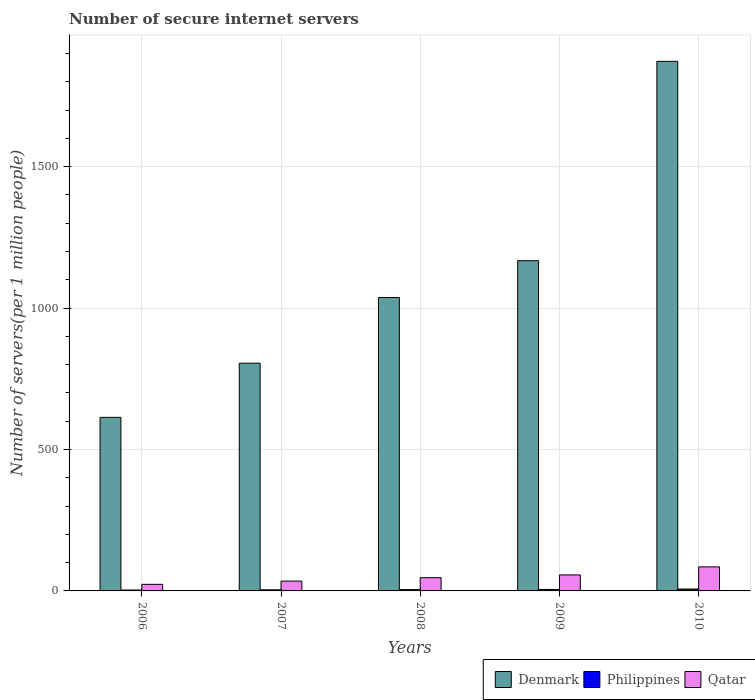How many different coloured bars are there?
Provide a short and direct response. 3. How many groups of bars are there?
Your response must be concise. 5. Are the number of bars per tick equal to the number of legend labels?
Ensure brevity in your answer.  Yes. Are the number of bars on each tick of the X-axis equal?
Your answer should be compact. Yes. How many bars are there on the 4th tick from the left?
Offer a terse response. 3. What is the label of the 4th group of bars from the left?
Your answer should be compact. 2009. In how many cases, is the number of bars for a given year not equal to the number of legend labels?
Offer a terse response. 0. What is the number of secure internet servers in Denmark in 2008?
Provide a succinct answer. 1037.2. Across all years, what is the maximum number of secure internet servers in Philippines?
Make the answer very short. 6.69. Across all years, what is the minimum number of secure internet servers in Qatar?
Your response must be concise. 23.27. What is the total number of secure internet servers in Denmark in the graph?
Give a very brief answer. 5495.44. What is the difference between the number of secure internet servers in Philippines in 2006 and that in 2009?
Your response must be concise. -2.05. What is the difference between the number of secure internet servers in Qatar in 2007 and the number of secure internet servers in Philippines in 2009?
Your response must be concise. 29.5. What is the average number of secure internet servers in Philippines per year?
Your response must be concise. 4.74. In the year 2008, what is the difference between the number of secure internet servers in Philippines and number of secure internet servers in Qatar?
Your response must be concise. -42.22. What is the ratio of the number of secure internet servers in Philippines in 2006 to that in 2008?
Provide a succinct answer. 0.71. Is the number of secure internet servers in Qatar in 2006 less than that in 2010?
Your answer should be compact. Yes. Is the difference between the number of secure internet servers in Philippines in 2006 and 2010 greater than the difference between the number of secure internet servers in Qatar in 2006 and 2010?
Make the answer very short. Yes. What is the difference between the highest and the second highest number of secure internet servers in Qatar?
Make the answer very short. 28.4. What is the difference between the highest and the lowest number of secure internet servers in Qatar?
Provide a short and direct response. 61.69. In how many years, is the number of secure internet servers in Denmark greater than the average number of secure internet servers in Denmark taken over all years?
Your response must be concise. 2. Is the sum of the number of secure internet servers in Philippines in 2006 and 2010 greater than the maximum number of secure internet servers in Denmark across all years?
Your answer should be compact. No. What does the 2nd bar from the left in 2008 represents?
Keep it short and to the point. Philippines. What does the 1st bar from the right in 2009 represents?
Provide a short and direct response. Qatar. Is it the case that in every year, the sum of the number of secure internet servers in Philippines and number of secure internet servers in Denmark is greater than the number of secure internet servers in Qatar?
Provide a succinct answer. Yes. Are the values on the major ticks of Y-axis written in scientific E-notation?
Offer a very short reply. No. Does the graph contain grids?
Provide a succinct answer. Yes. How many legend labels are there?
Keep it short and to the point. 3. How are the legend labels stacked?
Offer a very short reply. Horizontal. What is the title of the graph?
Your answer should be compact. Number of secure internet servers. What is the label or title of the X-axis?
Your response must be concise. Years. What is the label or title of the Y-axis?
Your answer should be very brief. Number of servers(per 1 million people). What is the Number of servers(per 1 million people) in Denmark in 2006?
Provide a short and direct response. 613.54. What is the Number of servers(per 1 million people) in Philippines in 2006?
Provide a succinct answer. 3.23. What is the Number of servers(per 1 million people) of Qatar in 2006?
Make the answer very short. 23.27. What is the Number of servers(per 1 million people) in Denmark in 2007?
Provide a short and direct response. 805.1. What is the Number of servers(per 1 million people) of Philippines in 2007?
Your answer should be very brief. 3.93. What is the Number of servers(per 1 million people) in Qatar in 2007?
Offer a terse response. 34.78. What is the Number of servers(per 1 million people) in Denmark in 2008?
Offer a very short reply. 1037.2. What is the Number of servers(per 1 million people) in Philippines in 2008?
Your answer should be very brief. 4.57. What is the Number of servers(per 1 million people) in Qatar in 2008?
Keep it short and to the point. 46.8. What is the Number of servers(per 1 million people) in Denmark in 2009?
Make the answer very short. 1167.46. What is the Number of servers(per 1 million people) in Philippines in 2009?
Ensure brevity in your answer.  5.28. What is the Number of servers(per 1 million people) of Qatar in 2009?
Ensure brevity in your answer.  56.56. What is the Number of servers(per 1 million people) of Denmark in 2010?
Offer a terse response. 1872.13. What is the Number of servers(per 1 million people) in Philippines in 2010?
Keep it short and to the point. 6.69. What is the Number of servers(per 1 million people) in Qatar in 2010?
Your response must be concise. 84.96. Across all years, what is the maximum Number of servers(per 1 million people) in Denmark?
Make the answer very short. 1872.13. Across all years, what is the maximum Number of servers(per 1 million people) in Philippines?
Your answer should be compact. 6.69. Across all years, what is the maximum Number of servers(per 1 million people) in Qatar?
Your answer should be very brief. 84.96. Across all years, what is the minimum Number of servers(per 1 million people) of Denmark?
Make the answer very short. 613.54. Across all years, what is the minimum Number of servers(per 1 million people) of Philippines?
Keep it short and to the point. 3.23. Across all years, what is the minimum Number of servers(per 1 million people) of Qatar?
Keep it short and to the point. 23.27. What is the total Number of servers(per 1 million people) of Denmark in the graph?
Your response must be concise. 5495.44. What is the total Number of servers(per 1 million people) in Philippines in the graph?
Your answer should be compact. 23.71. What is the total Number of servers(per 1 million people) in Qatar in the graph?
Keep it short and to the point. 246.37. What is the difference between the Number of servers(per 1 million people) in Denmark in 2006 and that in 2007?
Offer a terse response. -191.56. What is the difference between the Number of servers(per 1 million people) of Philippines in 2006 and that in 2007?
Give a very brief answer. -0.7. What is the difference between the Number of servers(per 1 million people) of Qatar in 2006 and that in 2007?
Your answer should be very brief. -11.51. What is the difference between the Number of servers(per 1 million people) in Denmark in 2006 and that in 2008?
Ensure brevity in your answer.  -423.66. What is the difference between the Number of servers(per 1 million people) of Philippines in 2006 and that in 2008?
Provide a short and direct response. -1.34. What is the difference between the Number of servers(per 1 million people) in Qatar in 2006 and that in 2008?
Your answer should be compact. -23.53. What is the difference between the Number of servers(per 1 million people) of Denmark in 2006 and that in 2009?
Give a very brief answer. -553.92. What is the difference between the Number of servers(per 1 million people) in Philippines in 2006 and that in 2009?
Keep it short and to the point. -2.05. What is the difference between the Number of servers(per 1 million people) of Qatar in 2006 and that in 2009?
Provide a short and direct response. -33.29. What is the difference between the Number of servers(per 1 million people) of Denmark in 2006 and that in 2010?
Your response must be concise. -1258.59. What is the difference between the Number of servers(per 1 million people) of Philippines in 2006 and that in 2010?
Give a very brief answer. -3.45. What is the difference between the Number of servers(per 1 million people) in Qatar in 2006 and that in 2010?
Offer a terse response. -61.69. What is the difference between the Number of servers(per 1 million people) of Denmark in 2007 and that in 2008?
Provide a succinct answer. -232.1. What is the difference between the Number of servers(per 1 million people) of Philippines in 2007 and that in 2008?
Provide a short and direct response. -0.64. What is the difference between the Number of servers(per 1 million people) of Qatar in 2007 and that in 2008?
Your response must be concise. -12.02. What is the difference between the Number of servers(per 1 million people) of Denmark in 2007 and that in 2009?
Your answer should be very brief. -362.36. What is the difference between the Number of servers(per 1 million people) of Philippines in 2007 and that in 2009?
Your answer should be very brief. -1.35. What is the difference between the Number of servers(per 1 million people) of Qatar in 2007 and that in 2009?
Ensure brevity in your answer.  -21.79. What is the difference between the Number of servers(per 1 million people) in Denmark in 2007 and that in 2010?
Make the answer very short. -1067.03. What is the difference between the Number of servers(per 1 million people) of Philippines in 2007 and that in 2010?
Keep it short and to the point. -2.75. What is the difference between the Number of servers(per 1 million people) in Qatar in 2007 and that in 2010?
Ensure brevity in your answer.  -50.18. What is the difference between the Number of servers(per 1 million people) in Denmark in 2008 and that in 2009?
Give a very brief answer. -130.26. What is the difference between the Number of servers(per 1 million people) of Philippines in 2008 and that in 2009?
Give a very brief answer. -0.71. What is the difference between the Number of servers(per 1 million people) of Qatar in 2008 and that in 2009?
Offer a very short reply. -9.77. What is the difference between the Number of servers(per 1 million people) in Denmark in 2008 and that in 2010?
Your answer should be very brief. -834.93. What is the difference between the Number of servers(per 1 million people) in Philippines in 2008 and that in 2010?
Your answer should be compact. -2.11. What is the difference between the Number of servers(per 1 million people) of Qatar in 2008 and that in 2010?
Your response must be concise. -38.16. What is the difference between the Number of servers(per 1 million people) of Denmark in 2009 and that in 2010?
Make the answer very short. -704.67. What is the difference between the Number of servers(per 1 million people) in Philippines in 2009 and that in 2010?
Ensure brevity in your answer.  -1.4. What is the difference between the Number of servers(per 1 million people) of Qatar in 2009 and that in 2010?
Provide a short and direct response. -28.4. What is the difference between the Number of servers(per 1 million people) in Denmark in 2006 and the Number of servers(per 1 million people) in Philippines in 2007?
Offer a very short reply. 609.61. What is the difference between the Number of servers(per 1 million people) of Denmark in 2006 and the Number of servers(per 1 million people) of Qatar in 2007?
Ensure brevity in your answer.  578.77. What is the difference between the Number of servers(per 1 million people) in Philippines in 2006 and the Number of servers(per 1 million people) in Qatar in 2007?
Provide a succinct answer. -31.55. What is the difference between the Number of servers(per 1 million people) of Denmark in 2006 and the Number of servers(per 1 million people) of Philippines in 2008?
Your answer should be compact. 608.97. What is the difference between the Number of servers(per 1 million people) in Denmark in 2006 and the Number of servers(per 1 million people) in Qatar in 2008?
Give a very brief answer. 566.75. What is the difference between the Number of servers(per 1 million people) of Philippines in 2006 and the Number of servers(per 1 million people) of Qatar in 2008?
Keep it short and to the point. -43.57. What is the difference between the Number of servers(per 1 million people) of Denmark in 2006 and the Number of servers(per 1 million people) of Philippines in 2009?
Make the answer very short. 608.26. What is the difference between the Number of servers(per 1 million people) of Denmark in 2006 and the Number of servers(per 1 million people) of Qatar in 2009?
Your answer should be compact. 556.98. What is the difference between the Number of servers(per 1 million people) of Philippines in 2006 and the Number of servers(per 1 million people) of Qatar in 2009?
Keep it short and to the point. -53.33. What is the difference between the Number of servers(per 1 million people) in Denmark in 2006 and the Number of servers(per 1 million people) in Philippines in 2010?
Your response must be concise. 606.86. What is the difference between the Number of servers(per 1 million people) in Denmark in 2006 and the Number of servers(per 1 million people) in Qatar in 2010?
Offer a terse response. 528.58. What is the difference between the Number of servers(per 1 million people) of Philippines in 2006 and the Number of servers(per 1 million people) of Qatar in 2010?
Give a very brief answer. -81.73. What is the difference between the Number of servers(per 1 million people) of Denmark in 2007 and the Number of servers(per 1 million people) of Philippines in 2008?
Give a very brief answer. 800.53. What is the difference between the Number of servers(per 1 million people) in Denmark in 2007 and the Number of servers(per 1 million people) in Qatar in 2008?
Give a very brief answer. 758.3. What is the difference between the Number of servers(per 1 million people) in Philippines in 2007 and the Number of servers(per 1 million people) in Qatar in 2008?
Offer a terse response. -42.86. What is the difference between the Number of servers(per 1 million people) of Denmark in 2007 and the Number of servers(per 1 million people) of Philippines in 2009?
Offer a very short reply. 799.82. What is the difference between the Number of servers(per 1 million people) in Denmark in 2007 and the Number of servers(per 1 million people) in Qatar in 2009?
Your answer should be compact. 748.54. What is the difference between the Number of servers(per 1 million people) in Philippines in 2007 and the Number of servers(per 1 million people) in Qatar in 2009?
Your answer should be compact. -52.63. What is the difference between the Number of servers(per 1 million people) in Denmark in 2007 and the Number of servers(per 1 million people) in Philippines in 2010?
Provide a short and direct response. 798.41. What is the difference between the Number of servers(per 1 million people) of Denmark in 2007 and the Number of servers(per 1 million people) of Qatar in 2010?
Ensure brevity in your answer.  720.14. What is the difference between the Number of servers(per 1 million people) of Philippines in 2007 and the Number of servers(per 1 million people) of Qatar in 2010?
Your answer should be compact. -81.03. What is the difference between the Number of servers(per 1 million people) in Denmark in 2008 and the Number of servers(per 1 million people) in Philippines in 2009?
Provide a short and direct response. 1031.92. What is the difference between the Number of servers(per 1 million people) of Denmark in 2008 and the Number of servers(per 1 million people) of Qatar in 2009?
Offer a very short reply. 980.64. What is the difference between the Number of servers(per 1 million people) in Philippines in 2008 and the Number of servers(per 1 million people) in Qatar in 2009?
Provide a succinct answer. -51.99. What is the difference between the Number of servers(per 1 million people) of Denmark in 2008 and the Number of servers(per 1 million people) of Philippines in 2010?
Provide a short and direct response. 1030.52. What is the difference between the Number of servers(per 1 million people) of Denmark in 2008 and the Number of servers(per 1 million people) of Qatar in 2010?
Your response must be concise. 952.24. What is the difference between the Number of servers(per 1 million people) of Philippines in 2008 and the Number of servers(per 1 million people) of Qatar in 2010?
Your answer should be compact. -80.39. What is the difference between the Number of servers(per 1 million people) of Denmark in 2009 and the Number of servers(per 1 million people) of Philippines in 2010?
Offer a terse response. 1160.78. What is the difference between the Number of servers(per 1 million people) of Denmark in 2009 and the Number of servers(per 1 million people) of Qatar in 2010?
Offer a terse response. 1082.5. What is the difference between the Number of servers(per 1 million people) in Philippines in 2009 and the Number of servers(per 1 million people) in Qatar in 2010?
Ensure brevity in your answer.  -79.68. What is the average Number of servers(per 1 million people) of Denmark per year?
Offer a terse response. 1099.09. What is the average Number of servers(per 1 million people) of Philippines per year?
Your answer should be compact. 4.74. What is the average Number of servers(per 1 million people) in Qatar per year?
Keep it short and to the point. 49.27. In the year 2006, what is the difference between the Number of servers(per 1 million people) in Denmark and Number of servers(per 1 million people) in Philippines?
Give a very brief answer. 610.31. In the year 2006, what is the difference between the Number of servers(per 1 million people) of Denmark and Number of servers(per 1 million people) of Qatar?
Provide a short and direct response. 590.27. In the year 2006, what is the difference between the Number of servers(per 1 million people) of Philippines and Number of servers(per 1 million people) of Qatar?
Make the answer very short. -20.04. In the year 2007, what is the difference between the Number of servers(per 1 million people) of Denmark and Number of servers(per 1 million people) of Philippines?
Your answer should be compact. 801.17. In the year 2007, what is the difference between the Number of servers(per 1 million people) of Denmark and Number of servers(per 1 million people) of Qatar?
Provide a short and direct response. 770.32. In the year 2007, what is the difference between the Number of servers(per 1 million people) of Philippines and Number of servers(per 1 million people) of Qatar?
Provide a short and direct response. -30.84. In the year 2008, what is the difference between the Number of servers(per 1 million people) of Denmark and Number of servers(per 1 million people) of Philippines?
Provide a short and direct response. 1032.63. In the year 2008, what is the difference between the Number of servers(per 1 million people) in Denmark and Number of servers(per 1 million people) in Qatar?
Offer a very short reply. 990.41. In the year 2008, what is the difference between the Number of servers(per 1 million people) in Philippines and Number of servers(per 1 million people) in Qatar?
Give a very brief answer. -42.22. In the year 2009, what is the difference between the Number of servers(per 1 million people) in Denmark and Number of servers(per 1 million people) in Philippines?
Make the answer very short. 1162.18. In the year 2009, what is the difference between the Number of servers(per 1 million people) in Denmark and Number of servers(per 1 million people) in Qatar?
Your answer should be compact. 1110.9. In the year 2009, what is the difference between the Number of servers(per 1 million people) in Philippines and Number of servers(per 1 million people) in Qatar?
Your answer should be compact. -51.28. In the year 2010, what is the difference between the Number of servers(per 1 million people) of Denmark and Number of servers(per 1 million people) of Philippines?
Your answer should be compact. 1865.45. In the year 2010, what is the difference between the Number of servers(per 1 million people) in Denmark and Number of servers(per 1 million people) in Qatar?
Your response must be concise. 1787.17. In the year 2010, what is the difference between the Number of servers(per 1 million people) of Philippines and Number of servers(per 1 million people) of Qatar?
Make the answer very short. -78.28. What is the ratio of the Number of servers(per 1 million people) in Denmark in 2006 to that in 2007?
Offer a terse response. 0.76. What is the ratio of the Number of servers(per 1 million people) in Philippines in 2006 to that in 2007?
Offer a terse response. 0.82. What is the ratio of the Number of servers(per 1 million people) in Qatar in 2006 to that in 2007?
Your response must be concise. 0.67. What is the ratio of the Number of servers(per 1 million people) of Denmark in 2006 to that in 2008?
Make the answer very short. 0.59. What is the ratio of the Number of servers(per 1 million people) of Philippines in 2006 to that in 2008?
Provide a short and direct response. 0.71. What is the ratio of the Number of servers(per 1 million people) of Qatar in 2006 to that in 2008?
Your answer should be very brief. 0.5. What is the ratio of the Number of servers(per 1 million people) of Denmark in 2006 to that in 2009?
Your response must be concise. 0.53. What is the ratio of the Number of servers(per 1 million people) of Philippines in 2006 to that in 2009?
Ensure brevity in your answer.  0.61. What is the ratio of the Number of servers(per 1 million people) of Qatar in 2006 to that in 2009?
Ensure brevity in your answer.  0.41. What is the ratio of the Number of servers(per 1 million people) in Denmark in 2006 to that in 2010?
Your answer should be very brief. 0.33. What is the ratio of the Number of servers(per 1 million people) in Philippines in 2006 to that in 2010?
Give a very brief answer. 0.48. What is the ratio of the Number of servers(per 1 million people) of Qatar in 2006 to that in 2010?
Your response must be concise. 0.27. What is the ratio of the Number of servers(per 1 million people) of Denmark in 2007 to that in 2008?
Provide a short and direct response. 0.78. What is the ratio of the Number of servers(per 1 million people) in Philippines in 2007 to that in 2008?
Offer a very short reply. 0.86. What is the ratio of the Number of servers(per 1 million people) in Qatar in 2007 to that in 2008?
Keep it short and to the point. 0.74. What is the ratio of the Number of servers(per 1 million people) in Denmark in 2007 to that in 2009?
Your response must be concise. 0.69. What is the ratio of the Number of servers(per 1 million people) of Philippines in 2007 to that in 2009?
Provide a succinct answer. 0.74. What is the ratio of the Number of servers(per 1 million people) in Qatar in 2007 to that in 2009?
Provide a succinct answer. 0.61. What is the ratio of the Number of servers(per 1 million people) of Denmark in 2007 to that in 2010?
Provide a succinct answer. 0.43. What is the ratio of the Number of servers(per 1 million people) in Philippines in 2007 to that in 2010?
Your answer should be very brief. 0.59. What is the ratio of the Number of servers(per 1 million people) in Qatar in 2007 to that in 2010?
Give a very brief answer. 0.41. What is the ratio of the Number of servers(per 1 million people) in Denmark in 2008 to that in 2009?
Offer a very short reply. 0.89. What is the ratio of the Number of servers(per 1 million people) of Philippines in 2008 to that in 2009?
Your response must be concise. 0.87. What is the ratio of the Number of servers(per 1 million people) in Qatar in 2008 to that in 2009?
Provide a succinct answer. 0.83. What is the ratio of the Number of servers(per 1 million people) in Denmark in 2008 to that in 2010?
Provide a succinct answer. 0.55. What is the ratio of the Number of servers(per 1 million people) in Philippines in 2008 to that in 2010?
Your response must be concise. 0.68. What is the ratio of the Number of servers(per 1 million people) in Qatar in 2008 to that in 2010?
Your answer should be compact. 0.55. What is the ratio of the Number of servers(per 1 million people) of Denmark in 2009 to that in 2010?
Keep it short and to the point. 0.62. What is the ratio of the Number of servers(per 1 million people) of Philippines in 2009 to that in 2010?
Your answer should be very brief. 0.79. What is the ratio of the Number of servers(per 1 million people) of Qatar in 2009 to that in 2010?
Offer a very short reply. 0.67. What is the difference between the highest and the second highest Number of servers(per 1 million people) of Denmark?
Offer a very short reply. 704.67. What is the difference between the highest and the second highest Number of servers(per 1 million people) in Philippines?
Give a very brief answer. 1.4. What is the difference between the highest and the second highest Number of servers(per 1 million people) of Qatar?
Give a very brief answer. 28.4. What is the difference between the highest and the lowest Number of servers(per 1 million people) in Denmark?
Offer a terse response. 1258.59. What is the difference between the highest and the lowest Number of servers(per 1 million people) of Philippines?
Your response must be concise. 3.45. What is the difference between the highest and the lowest Number of servers(per 1 million people) in Qatar?
Keep it short and to the point. 61.69. 